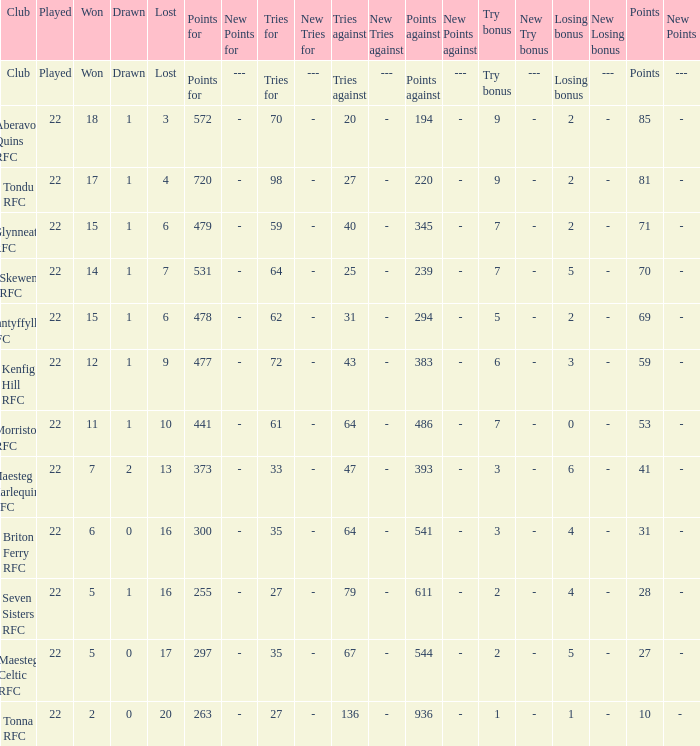How many attempts against did the club with 62 attempts for achieve? 31.0. Give me the full table as a dictionary. {'header': ['Club', 'Played', 'Won', 'Drawn', 'Lost', 'Points for', 'New Points for', 'Tries for', 'New Tries for', 'Tries against', 'New Tries against', 'Points against', 'New Points against', 'Try bonus', 'New Try bonus', 'Losing bonus', 'New Losing bonus', 'Points', 'New Points'], 'rows': [['Club', 'Played', 'Won', 'Drawn', 'Lost', 'Points for', '---', 'Tries for', '---', 'Tries against', '---', 'Points against', '---', 'Try bonus', '---', 'Losing bonus', '---', 'Points', '---'], ['Aberavon Quins RFC', '22', '18', '1', '3', '572', '-', '70', '-', '20', '-', '194', '-', '9', '-', '2', '-', '85', '-'], ['Tondu RFC', '22', '17', '1', '4', '720', '-', '98', '-', '27', '-', '220', '-', '9', '-', '2', '-', '81', '-'], ['Glynneath RFC', '22', '15', '1', '6', '479', '-', '59', '-', '40', '-', '345', '-', '7', '-', '2', '-', '71', '-'], ['Skewen RFC', '22', '14', '1', '7', '531', '-', '64', '-', '25', '-', '239', '-', '7', '-', '5', '-', '70', '-'], ['Nantyffyllon RFC', '22', '15', '1', '6', '478', '-', '62', '-', '31', '-', '294', '-', '5', '-', '2', '-', '69', '-'], ['Kenfig Hill RFC', '22', '12', '1', '9', '477', '-', '72', '-', '43', '-', '383', '-', '6', '-', '3', '-', '59', '-'], ['Morriston RFC', '22', '11', '1', '10', '441', '-', '61', '-', '64', '-', '486', '-', '7', '-', '0', '-', '53', '-'], ['Maesteg Harlequins RFC', '22', '7', '2', '13', '373', '-', '33', '-', '47', '-', '393', '-', '3', '-', '6', '-', '41', '-'], ['Briton Ferry RFC', '22', '6', '0', '16', '300', '-', '35', '-', '64', '-', '541', '-', '3', '-', '4', '-', '31', '-'], ['Seven Sisters RFC', '22', '5', '1', '16', '255', '-', '27', '-', '79', '-', '611', '-', '2', '-', '4', '-', '28', '-'], ['Maesteg Celtic RFC', '22', '5', '0', '17', '297', '-', '35', '-', '67', '-', '544', '-', '2', '-', '5', '-', '27', '-'], ['Tonna RFC', '22', '2', '0', '20', '263', '-', '27', '-', '136', '-', '936', '-', '1', '-', '1', '-', '10', '- ']]} 